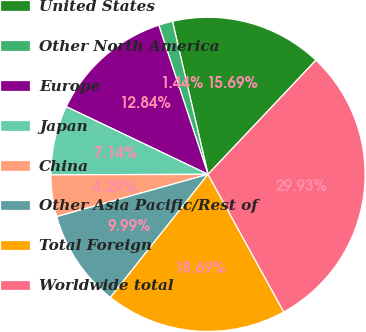Convert chart to OTSL. <chart><loc_0><loc_0><loc_500><loc_500><pie_chart><fcel>United States<fcel>Other North America<fcel>Europe<fcel>Japan<fcel>China<fcel>Other Asia Pacific/Rest of<fcel>Total Foreign<fcel>Worldwide total<nl><fcel>15.69%<fcel>1.44%<fcel>12.84%<fcel>7.14%<fcel>4.29%<fcel>9.99%<fcel>18.69%<fcel>29.94%<nl></chart> 